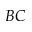Convert formula to latex. <formula><loc_0><loc_0><loc_500><loc_500>B C</formula> 